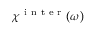<formula> <loc_0><loc_0><loc_500><loc_500>\chi ^ { i n t e r } ( \omega )</formula> 